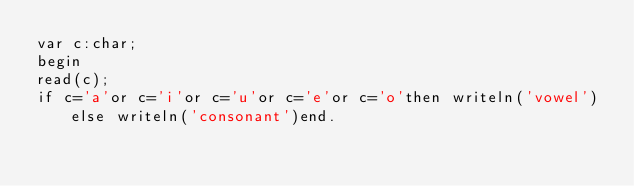<code> <loc_0><loc_0><loc_500><loc_500><_Pascal_>var c:char;
begin
read(c);
if c='a'or c='i'or c='u'or c='e'or c='o'then writeln('vowel')else writeln('consonant')end.</code> 